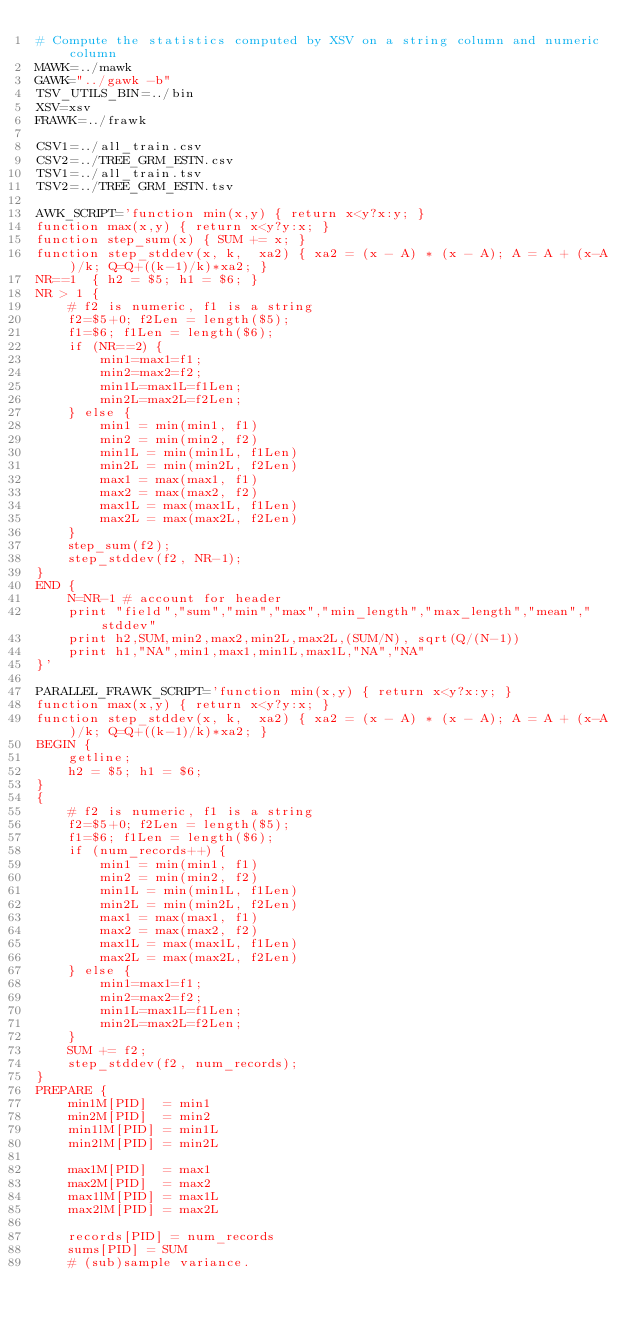Convert code to text. <code><loc_0><loc_0><loc_500><loc_500><_Bash_># Compute the statistics computed by XSV on a string column and numeric column
MAWK=../mawk
GAWK="../gawk -b"
TSV_UTILS_BIN=../bin
XSV=xsv
FRAWK=../frawk

CSV1=../all_train.csv
CSV2=../TREE_GRM_ESTN.csv
TSV1=../all_train.tsv
TSV2=../TREE_GRM_ESTN.tsv

AWK_SCRIPT='function min(x,y) { return x<y?x:y; }
function max(x,y) { return x<y?y:x; }
function step_sum(x) { SUM += x; }
function step_stddev(x, k,  xa2) { xa2 = (x - A) * (x - A); A = A + (x-A)/k; Q=Q+((k-1)/k)*xa2; }
NR==1  { h2 = $5; h1 = $6; }
NR > 1 {
    # f2 is numeric, f1 is a string
    f2=$5+0; f2Len = length($5);
    f1=$6; f1Len = length($6);
    if (NR==2) {
        min1=max1=f1;
        min2=max2=f2;
        min1L=max1L=f1Len;
        min2L=max2L=f2Len;
    } else {
        min1 = min(min1, f1)
        min2 = min(min2, f2)
        min1L = min(min1L, f1Len)
        min2L = min(min2L, f2Len)
        max1 = max(max1, f1)
        max2 = max(max2, f2)
        max1L = max(max1L, f1Len)
        max2L = max(max2L, f2Len)
    }
    step_sum(f2);
    step_stddev(f2, NR-1);
}
END {
    N=NR-1 # account for header
    print "field","sum","min","max","min_length","max_length","mean","stddev"
    print h2,SUM,min2,max2,min2L,max2L,(SUM/N), sqrt(Q/(N-1))
    print h1,"NA",min1,max1,min1L,max1L,"NA","NA"
}'

PARALLEL_FRAWK_SCRIPT='function min(x,y) { return x<y?x:y; }
function max(x,y) { return x<y?y:x; }
function step_stddev(x, k,  xa2) { xa2 = (x - A) * (x - A); A = A + (x-A)/k; Q=Q+((k-1)/k)*xa2; }
BEGIN {
    getline; 
    h2 = $5; h1 = $6;
}
{
    # f2 is numeric, f1 is a string
    f2=$5+0; f2Len = length($5);
    f1=$6; f1Len = length($6);
    if (num_records++) {
        min1 = min(min1, f1)
        min2 = min(min2, f2)
        min1L = min(min1L, f1Len)
        min2L = min(min2L, f2Len)
        max1 = max(max1, f1)
        max2 = max(max2, f2)
        max1L = max(max1L, f1Len)
        max2L = max(max2L, f2Len)
    } else {
        min1=max1=f1;
        min2=max2=f2;
        min1L=max1L=f1Len;
        min2L=max2L=f2Len;
    }
    SUM += f2;
    step_stddev(f2, num_records);
}
PREPARE {
    min1M[PID]  = min1
    min2M[PID]  = min2
    min1lM[PID] = min1L
    min2lM[PID] = min2L

    max1M[PID]  = max1
    max2M[PID]  = max2
    max1lM[PID] = max1L
    max2lM[PID] = max2L

    records[PID] = num_records
    sums[PID] = SUM
    # (sub)sample variance.</code> 